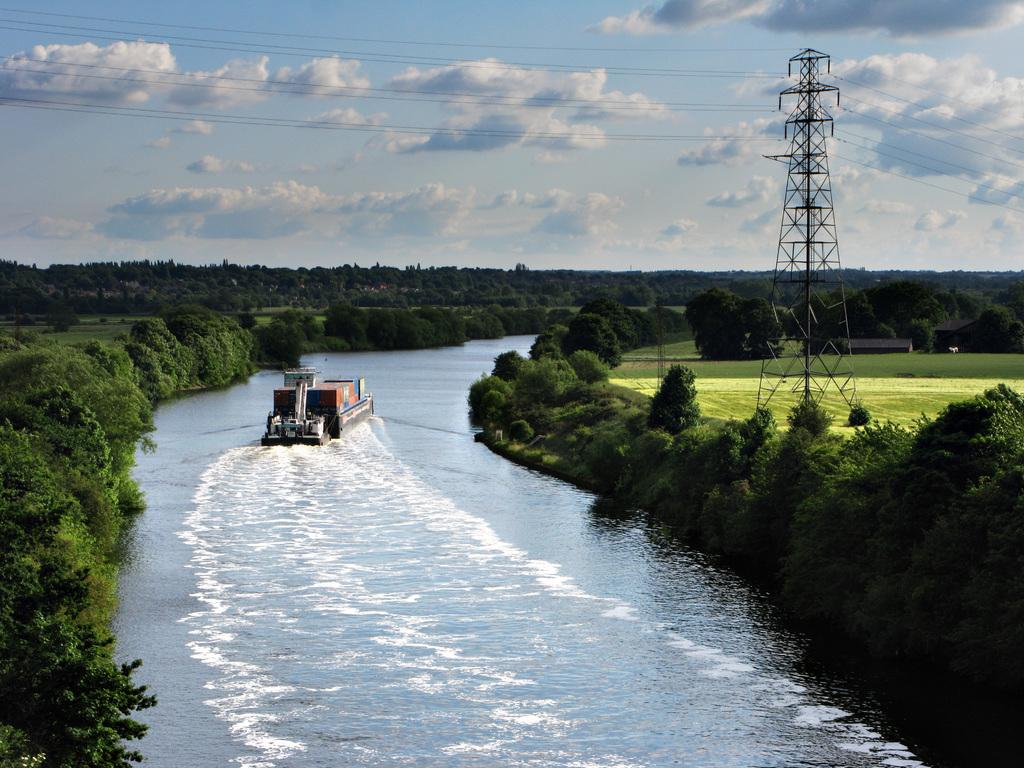What is the main subject of the image? There is a boat sailing on the water in the image. What type of vegetation can be seen in the image? There are trees and grass visible in the image. What structure is present in the image? There is a tower with wires in the image. How would you describe the sky in the image? The sky is cloudy at the top of the image. What type of payment is being made in the image? There is no indication of any payment being made in the image. How does the rainstorm affect the boat in the image? There is no rainstorm present in the image; the sky is cloudy but not raining. 